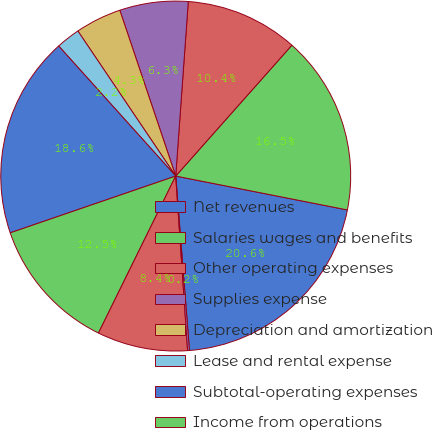Convert chart to OTSL. <chart><loc_0><loc_0><loc_500><loc_500><pie_chart><fcel>Net revenues<fcel>Salaries wages and benefits<fcel>Other operating expenses<fcel>Supplies expense<fcel>Depreciation and amortization<fcel>Lease and rental expense<fcel>Subtotal-operating expenses<fcel>Income from operations<fcel>Interest expense net<fcel>Other (income) expense net<nl><fcel>20.65%<fcel>16.55%<fcel>10.41%<fcel>6.32%<fcel>4.27%<fcel>2.22%<fcel>18.6%<fcel>12.46%<fcel>8.36%<fcel>0.17%<nl></chart> 